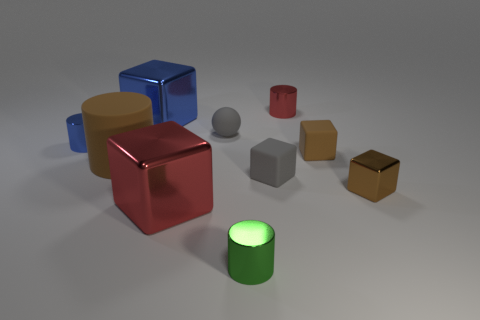How many objects are big cylinders or large metal objects?
Your answer should be compact. 3. There is a small sphere; how many small red metal things are left of it?
Give a very brief answer. 0. Is the color of the tiny sphere the same as the tiny metal cube?
Make the answer very short. No. The brown object that is made of the same material as the big red thing is what shape?
Ensure brevity in your answer.  Cube. There is a blue metal thing that is in front of the large blue metal thing; is it the same shape as the brown metallic thing?
Give a very brief answer. No. How many yellow objects are large matte objects or small spheres?
Provide a succinct answer. 0. Are there the same number of tiny red metal cylinders on the left side of the big blue shiny block and small red metal things behind the brown shiny object?
Provide a short and direct response. No. What is the color of the matte object that is to the right of the metal cylinder that is behind the blue thing that is in front of the small gray ball?
Your response must be concise. Brown. Is there any other thing that is the same color as the large rubber thing?
Your answer should be very brief. Yes. There is a matte object that is the same color as the small sphere; what is its shape?
Keep it short and to the point. Cube. 